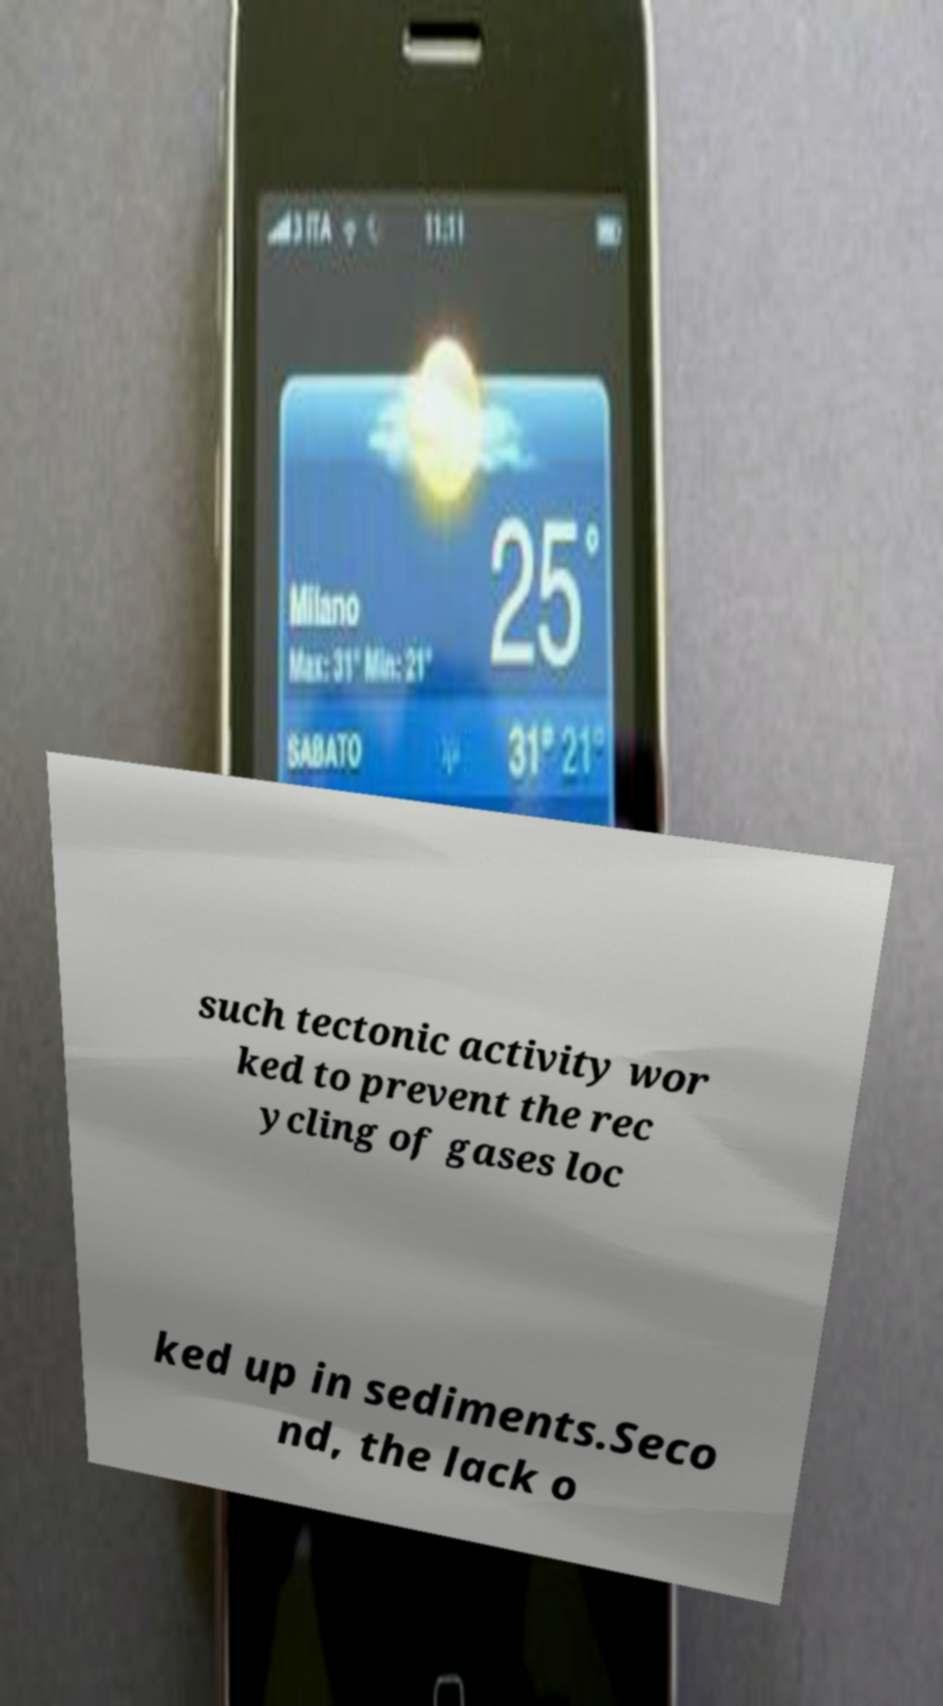Can you accurately transcribe the text from the provided image for me? such tectonic activity wor ked to prevent the rec ycling of gases loc ked up in sediments.Seco nd, the lack o 